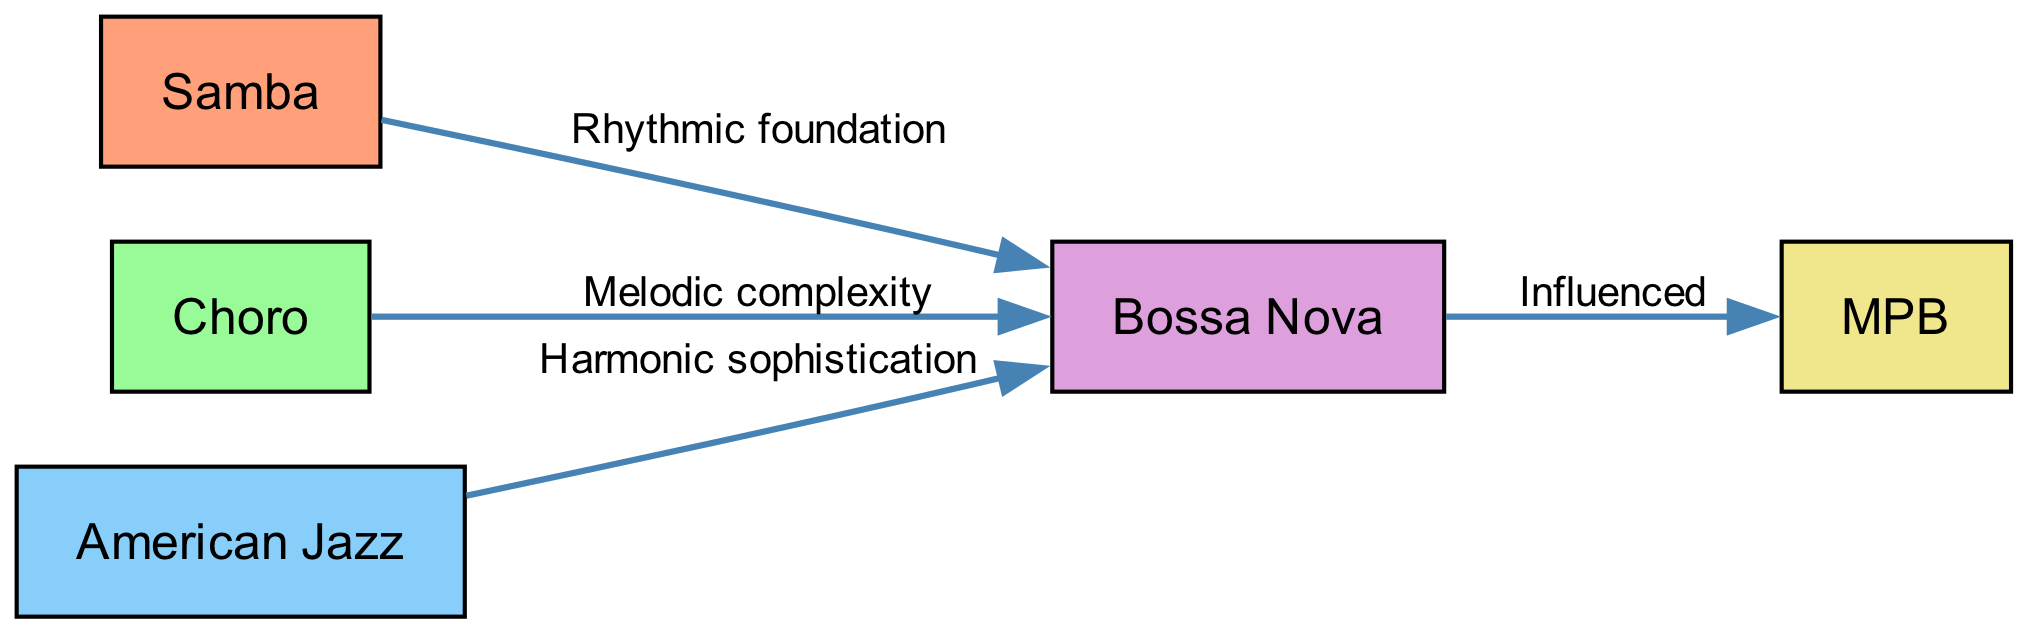What is the first node in the diagram? The diagram starts with the node labeled "Samba," which is the origin of the food chain as indicated by its position.
Answer: Samba How many nodes are present in the diagram? By counting the listed nodes in the data, we find there are a total of five distinct nodes: Samba, Choro, American Jazz, Bossa Nova, and MPB.
Answer: 5 What influence does Choro have on Bossa Nova? The edge connecting Choro to Bossa Nova is labeled "Melodic complexity," indicating the specific influence that Choro contributes to Bossa Nova.
Answer: Melodic complexity Which node directly leads to MPB? The only edge that points to MPB in the diagram originates from Bossa Nova, indicating its direct influence on MPB.
Answer: Bossa Nova What is the relationship between Jazz and Bossa Nova? The connection is represented by an edge labeled "Harmonic sophistication," which describes the influence Jazz has on Bossa Nova.
Answer: Harmonic sophistication How many edges are in the diagram? By counting the connections or edges in the data provided, we see there are four edges described in total.
Answer: 4 Which musical genre is considered the rhythmic foundation of Bossa Nova? The diagram states that Samba is the rhythmic foundation of Bossa Nova, making it a foundational influence.
Answer: Samba What do all the arrows in the diagram represent? Each arrow illustrates a flow or influence from one musical genre to the next, showing how one genre contributes to the characteristics of another.
Answer: Influence What type of influence does Samba provide to Bossa Nova? The specific influence is described on the edge between Samba and Bossa Nova, which is labeled "Rhythmic foundation."
Answer: Rhythmic foundation 